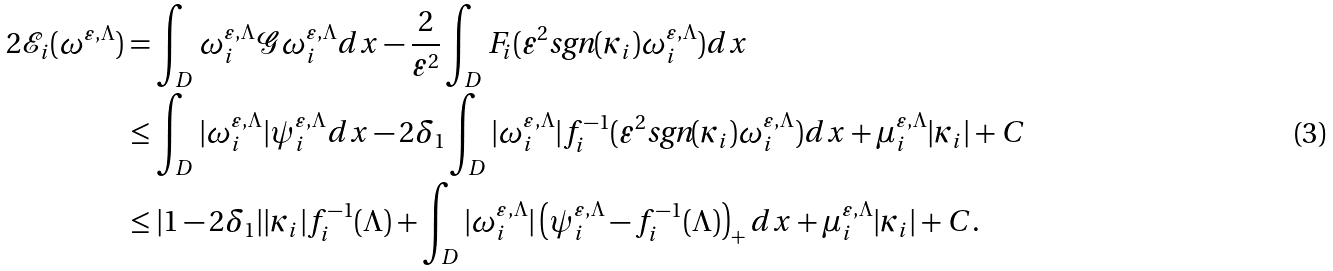<formula> <loc_0><loc_0><loc_500><loc_500>2 \mathcal { E } _ { i } ( \omega ^ { \varepsilon , \Lambda } ) & = \int _ { D } \omega ^ { \varepsilon , \Lambda } _ { i } \mathcal { G } \omega ^ { \varepsilon , \Lambda } _ { i } d x - \frac { 2 } { \varepsilon ^ { 2 } } \int _ { D } F _ { i } ( \varepsilon ^ { 2 } \text {sgn} ( \kappa _ { i } ) \omega ^ { \varepsilon , \Lambda } _ { i } ) d x \\ & \leq \int _ { D } | \omega ^ { \varepsilon , \Lambda } _ { i } | \psi ^ { \varepsilon , \Lambda } _ { i } d x - 2 \delta _ { 1 } \int _ { D } | \omega ^ { \varepsilon , \Lambda } _ { i } | f _ { i } ^ { - 1 } ( \varepsilon ^ { 2 } \text {sgn} ( \kappa _ { i } ) \omega ^ { \varepsilon , \Lambda } _ { i } ) d x + \mu ^ { \varepsilon , \Lambda } _ { i } | \kappa _ { i } | + C \\ & \leq | 1 - 2 \delta _ { 1 } | | \kappa _ { i } | f _ { i } ^ { - 1 } ( \Lambda ) + \int _ { D } | \omega ^ { \varepsilon , \Lambda } _ { i } | \left ( \psi ^ { \varepsilon , \Lambda } _ { i } - f _ { i } ^ { - 1 } ( \Lambda ) \right ) _ { + } d x + \mu ^ { \varepsilon , \Lambda } _ { i } | \kappa _ { i } | + C .</formula> 